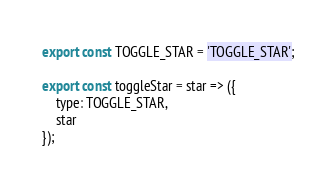<code> <loc_0><loc_0><loc_500><loc_500><_JavaScript_>export const TOGGLE_STAR = 'TOGGLE_STAR';

export const toggleStar = star => ({
    type: TOGGLE_STAR,
    star
});
</code> 